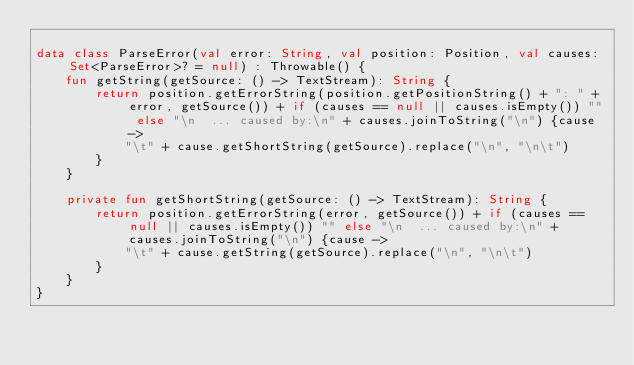<code> <loc_0><loc_0><loc_500><loc_500><_Kotlin_>
data class ParseError(val error: String, val position: Position, val causes: Set<ParseError>? = null) : Throwable() {
    fun getString(getSource: () -> TextStream): String {
        return position.getErrorString(position.getPositionString() + ": " + error, getSource()) + if (causes == null || causes.isEmpty()) "" else "\n  ... caused by:\n" + causes.joinToString("\n") {cause ->
            "\t" + cause.getShortString(getSource).replace("\n", "\n\t")
        }
    }

    private fun getShortString(getSource: () -> TextStream): String {
        return position.getErrorString(error, getSource()) + if (causes == null || causes.isEmpty()) "" else "\n  ... caused by:\n" + causes.joinToString("\n") {cause ->
            "\t" + cause.getString(getSource).replace("\n", "\n\t")
        }
    }
}
</code> 